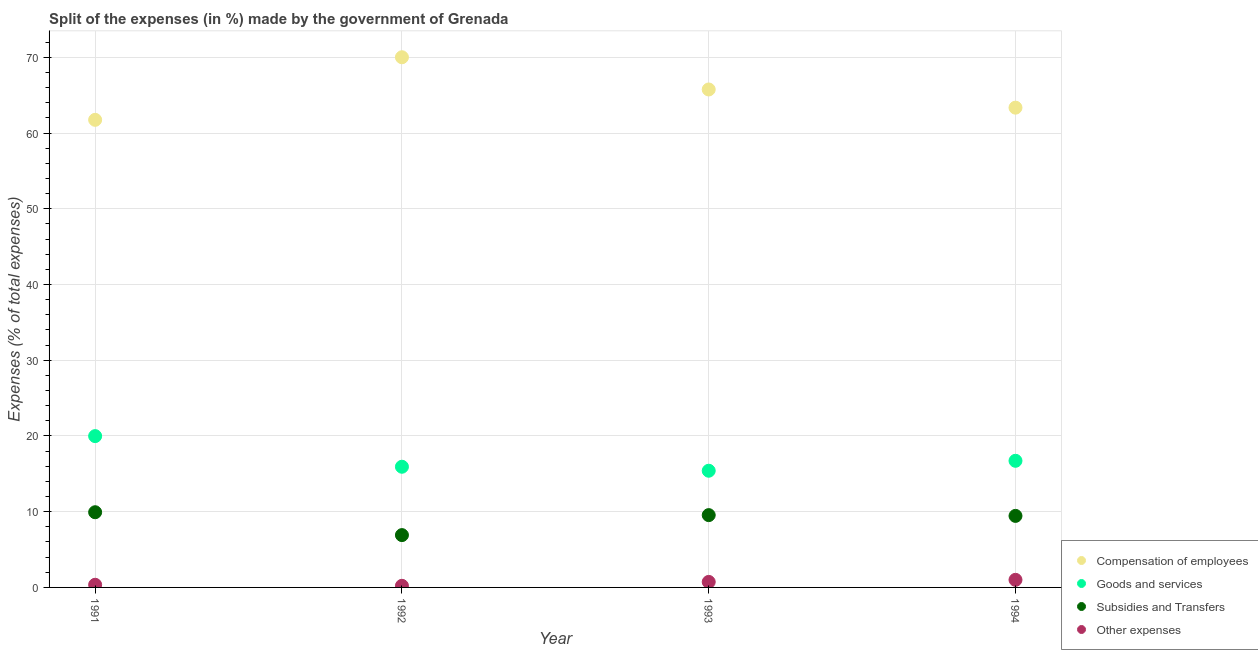Is the number of dotlines equal to the number of legend labels?
Offer a very short reply. Yes. What is the percentage of amount spent on subsidies in 1994?
Provide a short and direct response. 9.45. Across all years, what is the maximum percentage of amount spent on subsidies?
Your answer should be very brief. 9.93. Across all years, what is the minimum percentage of amount spent on subsidies?
Your answer should be very brief. 6.91. What is the total percentage of amount spent on subsidies in the graph?
Give a very brief answer. 35.84. What is the difference between the percentage of amount spent on compensation of employees in 1991 and that in 1993?
Make the answer very short. -4.01. What is the difference between the percentage of amount spent on subsidies in 1994 and the percentage of amount spent on compensation of employees in 1992?
Your answer should be compact. -60.57. What is the average percentage of amount spent on compensation of employees per year?
Ensure brevity in your answer.  65.23. In the year 1991, what is the difference between the percentage of amount spent on other expenses and percentage of amount spent on subsidies?
Your answer should be compact. -9.58. In how many years, is the percentage of amount spent on goods and services greater than 70 %?
Provide a short and direct response. 0. What is the ratio of the percentage of amount spent on goods and services in 1992 to that in 1993?
Your response must be concise. 1.03. Is the percentage of amount spent on goods and services in 1993 less than that in 1994?
Keep it short and to the point. Yes. What is the difference between the highest and the second highest percentage of amount spent on other expenses?
Ensure brevity in your answer.  0.27. What is the difference between the highest and the lowest percentage of amount spent on subsidies?
Offer a very short reply. 3.02. In how many years, is the percentage of amount spent on compensation of employees greater than the average percentage of amount spent on compensation of employees taken over all years?
Ensure brevity in your answer.  2. Is the sum of the percentage of amount spent on goods and services in 1992 and 1993 greater than the maximum percentage of amount spent on compensation of employees across all years?
Keep it short and to the point. No. Does the percentage of amount spent on subsidies monotonically increase over the years?
Provide a succinct answer. No. What is the difference between two consecutive major ticks on the Y-axis?
Offer a terse response. 10. How are the legend labels stacked?
Ensure brevity in your answer.  Vertical. What is the title of the graph?
Your answer should be very brief. Split of the expenses (in %) made by the government of Grenada. Does "Permission" appear as one of the legend labels in the graph?
Offer a very short reply. No. What is the label or title of the X-axis?
Keep it short and to the point. Year. What is the label or title of the Y-axis?
Provide a succinct answer. Expenses (% of total expenses). What is the Expenses (% of total expenses) in Compensation of employees in 1991?
Make the answer very short. 61.76. What is the Expenses (% of total expenses) of Goods and services in 1991?
Your answer should be very brief. 19.98. What is the Expenses (% of total expenses) in Subsidies and Transfers in 1991?
Make the answer very short. 9.93. What is the Expenses (% of total expenses) in Other expenses in 1991?
Your answer should be very brief. 0.35. What is the Expenses (% of total expenses) in Compensation of employees in 1992?
Provide a short and direct response. 70.02. What is the Expenses (% of total expenses) of Goods and services in 1992?
Your response must be concise. 15.94. What is the Expenses (% of total expenses) of Subsidies and Transfers in 1992?
Keep it short and to the point. 6.91. What is the Expenses (% of total expenses) of Other expenses in 1992?
Offer a terse response. 0.21. What is the Expenses (% of total expenses) of Compensation of employees in 1993?
Your response must be concise. 65.76. What is the Expenses (% of total expenses) of Goods and services in 1993?
Keep it short and to the point. 15.41. What is the Expenses (% of total expenses) in Subsidies and Transfers in 1993?
Keep it short and to the point. 9.55. What is the Expenses (% of total expenses) in Other expenses in 1993?
Provide a short and direct response. 0.73. What is the Expenses (% of total expenses) in Compensation of employees in 1994?
Give a very brief answer. 63.36. What is the Expenses (% of total expenses) in Goods and services in 1994?
Offer a terse response. 16.72. What is the Expenses (% of total expenses) in Subsidies and Transfers in 1994?
Provide a short and direct response. 9.45. What is the Expenses (% of total expenses) of Other expenses in 1994?
Ensure brevity in your answer.  1. Across all years, what is the maximum Expenses (% of total expenses) in Compensation of employees?
Your answer should be compact. 70.02. Across all years, what is the maximum Expenses (% of total expenses) in Goods and services?
Make the answer very short. 19.98. Across all years, what is the maximum Expenses (% of total expenses) of Subsidies and Transfers?
Ensure brevity in your answer.  9.93. Across all years, what is the maximum Expenses (% of total expenses) of Other expenses?
Provide a short and direct response. 1. Across all years, what is the minimum Expenses (% of total expenses) of Compensation of employees?
Provide a succinct answer. 61.76. Across all years, what is the minimum Expenses (% of total expenses) in Goods and services?
Give a very brief answer. 15.41. Across all years, what is the minimum Expenses (% of total expenses) of Subsidies and Transfers?
Offer a very short reply. 6.91. Across all years, what is the minimum Expenses (% of total expenses) of Other expenses?
Provide a short and direct response. 0.21. What is the total Expenses (% of total expenses) of Compensation of employees in the graph?
Give a very brief answer. 260.9. What is the total Expenses (% of total expenses) in Goods and services in the graph?
Provide a succinct answer. 68.06. What is the total Expenses (% of total expenses) in Subsidies and Transfers in the graph?
Your response must be concise. 35.84. What is the total Expenses (% of total expenses) of Other expenses in the graph?
Offer a terse response. 2.29. What is the difference between the Expenses (% of total expenses) in Compensation of employees in 1991 and that in 1992?
Keep it short and to the point. -8.26. What is the difference between the Expenses (% of total expenses) in Goods and services in 1991 and that in 1992?
Your answer should be very brief. 4.05. What is the difference between the Expenses (% of total expenses) in Subsidies and Transfers in 1991 and that in 1992?
Provide a succinct answer. 3.02. What is the difference between the Expenses (% of total expenses) of Other expenses in 1991 and that in 1992?
Offer a very short reply. 0.14. What is the difference between the Expenses (% of total expenses) in Compensation of employees in 1991 and that in 1993?
Make the answer very short. -4.01. What is the difference between the Expenses (% of total expenses) of Goods and services in 1991 and that in 1993?
Ensure brevity in your answer.  4.57. What is the difference between the Expenses (% of total expenses) in Subsidies and Transfers in 1991 and that in 1993?
Ensure brevity in your answer.  0.38. What is the difference between the Expenses (% of total expenses) of Other expenses in 1991 and that in 1993?
Provide a short and direct response. -0.38. What is the difference between the Expenses (% of total expenses) of Compensation of employees in 1991 and that in 1994?
Offer a terse response. -1.61. What is the difference between the Expenses (% of total expenses) in Goods and services in 1991 and that in 1994?
Your answer should be compact. 3.26. What is the difference between the Expenses (% of total expenses) of Subsidies and Transfers in 1991 and that in 1994?
Make the answer very short. 0.48. What is the difference between the Expenses (% of total expenses) of Other expenses in 1991 and that in 1994?
Give a very brief answer. -0.65. What is the difference between the Expenses (% of total expenses) in Compensation of employees in 1992 and that in 1993?
Your answer should be compact. 4.26. What is the difference between the Expenses (% of total expenses) in Goods and services in 1992 and that in 1993?
Provide a short and direct response. 0.53. What is the difference between the Expenses (% of total expenses) in Subsidies and Transfers in 1992 and that in 1993?
Offer a very short reply. -2.64. What is the difference between the Expenses (% of total expenses) of Other expenses in 1992 and that in 1993?
Offer a terse response. -0.52. What is the difference between the Expenses (% of total expenses) in Compensation of employees in 1992 and that in 1994?
Offer a terse response. 6.66. What is the difference between the Expenses (% of total expenses) of Goods and services in 1992 and that in 1994?
Your answer should be compact. -0.79. What is the difference between the Expenses (% of total expenses) in Subsidies and Transfers in 1992 and that in 1994?
Provide a succinct answer. -2.54. What is the difference between the Expenses (% of total expenses) in Other expenses in 1992 and that in 1994?
Ensure brevity in your answer.  -0.79. What is the difference between the Expenses (% of total expenses) of Compensation of employees in 1993 and that in 1994?
Provide a short and direct response. 2.4. What is the difference between the Expenses (% of total expenses) of Goods and services in 1993 and that in 1994?
Your answer should be compact. -1.31. What is the difference between the Expenses (% of total expenses) in Subsidies and Transfers in 1993 and that in 1994?
Keep it short and to the point. 0.1. What is the difference between the Expenses (% of total expenses) of Other expenses in 1993 and that in 1994?
Provide a succinct answer. -0.27. What is the difference between the Expenses (% of total expenses) of Compensation of employees in 1991 and the Expenses (% of total expenses) of Goods and services in 1992?
Give a very brief answer. 45.82. What is the difference between the Expenses (% of total expenses) in Compensation of employees in 1991 and the Expenses (% of total expenses) in Subsidies and Transfers in 1992?
Keep it short and to the point. 54.84. What is the difference between the Expenses (% of total expenses) of Compensation of employees in 1991 and the Expenses (% of total expenses) of Other expenses in 1992?
Provide a short and direct response. 61.54. What is the difference between the Expenses (% of total expenses) of Goods and services in 1991 and the Expenses (% of total expenses) of Subsidies and Transfers in 1992?
Your answer should be compact. 13.07. What is the difference between the Expenses (% of total expenses) in Goods and services in 1991 and the Expenses (% of total expenses) in Other expenses in 1992?
Offer a terse response. 19.77. What is the difference between the Expenses (% of total expenses) of Subsidies and Transfers in 1991 and the Expenses (% of total expenses) of Other expenses in 1992?
Offer a terse response. 9.72. What is the difference between the Expenses (% of total expenses) in Compensation of employees in 1991 and the Expenses (% of total expenses) in Goods and services in 1993?
Offer a very short reply. 46.34. What is the difference between the Expenses (% of total expenses) in Compensation of employees in 1991 and the Expenses (% of total expenses) in Subsidies and Transfers in 1993?
Offer a terse response. 52.21. What is the difference between the Expenses (% of total expenses) of Compensation of employees in 1991 and the Expenses (% of total expenses) of Other expenses in 1993?
Ensure brevity in your answer.  61.03. What is the difference between the Expenses (% of total expenses) in Goods and services in 1991 and the Expenses (% of total expenses) in Subsidies and Transfers in 1993?
Provide a short and direct response. 10.43. What is the difference between the Expenses (% of total expenses) in Goods and services in 1991 and the Expenses (% of total expenses) in Other expenses in 1993?
Provide a short and direct response. 19.26. What is the difference between the Expenses (% of total expenses) in Subsidies and Transfers in 1991 and the Expenses (% of total expenses) in Other expenses in 1993?
Offer a terse response. 9.2. What is the difference between the Expenses (% of total expenses) of Compensation of employees in 1991 and the Expenses (% of total expenses) of Goods and services in 1994?
Your answer should be compact. 45.03. What is the difference between the Expenses (% of total expenses) in Compensation of employees in 1991 and the Expenses (% of total expenses) in Subsidies and Transfers in 1994?
Ensure brevity in your answer.  52.31. What is the difference between the Expenses (% of total expenses) in Compensation of employees in 1991 and the Expenses (% of total expenses) in Other expenses in 1994?
Your answer should be very brief. 60.75. What is the difference between the Expenses (% of total expenses) of Goods and services in 1991 and the Expenses (% of total expenses) of Subsidies and Transfers in 1994?
Offer a terse response. 10.54. What is the difference between the Expenses (% of total expenses) of Goods and services in 1991 and the Expenses (% of total expenses) of Other expenses in 1994?
Provide a succinct answer. 18.98. What is the difference between the Expenses (% of total expenses) of Subsidies and Transfers in 1991 and the Expenses (% of total expenses) of Other expenses in 1994?
Your answer should be very brief. 8.93. What is the difference between the Expenses (% of total expenses) of Compensation of employees in 1992 and the Expenses (% of total expenses) of Goods and services in 1993?
Your answer should be very brief. 54.61. What is the difference between the Expenses (% of total expenses) of Compensation of employees in 1992 and the Expenses (% of total expenses) of Subsidies and Transfers in 1993?
Provide a short and direct response. 60.47. What is the difference between the Expenses (% of total expenses) in Compensation of employees in 1992 and the Expenses (% of total expenses) in Other expenses in 1993?
Keep it short and to the point. 69.29. What is the difference between the Expenses (% of total expenses) of Goods and services in 1992 and the Expenses (% of total expenses) of Subsidies and Transfers in 1993?
Your answer should be very brief. 6.39. What is the difference between the Expenses (% of total expenses) in Goods and services in 1992 and the Expenses (% of total expenses) in Other expenses in 1993?
Offer a very short reply. 15.21. What is the difference between the Expenses (% of total expenses) in Subsidies and Transfers in 1992 and the Expenses (% of total expenses) in Other expenses in 1993?
Offer a very short reply. 6.18. What is the difference between the Expenses (% of total expenses) in Compensation of employees in 1992 and the Expenses (% of total expenses) in Goods and services in 1994?
Provide a succinct answer. 53.3. What is the difference between the Expenses (% of total expenses) in Compensation of employees in 1992 and the Expenses (% of total expenses) in Subsidies and Transfers in 1994?
Offer a terse response. 60.57. What is the difference between the Expenses (% of total expenses) in Compensation of employees in 1992 and the Expenses (% of total expenses) in Other expenses in 1994?
Keep it short and to the point. 69.02. What is the difference between the Expenses (% of total expenses) in Goods and services in 1992 and the Expenses (% of total expenses) in Subsidies and Transfers in 1994?
Provide a short and direct response. 6.49. What is the difference between the Expenses (% of total expenses) of Goods and services in 1992 and the Expenses (% of total expenses) of Other expenses in 1994?
Keep it short and to the point. 14.94. What is the difference between the Expenses (% of total expenses) in Subsidies and Transfers in 1992 and the Expenses (% of total expenses) in Other expenses in 1994?
Provide a succinct answer. 5.91. What is the difference between the Expenses (% of total expenses) of Compensation of employees in 1993 and the Expenses (% of total expenses) of Goods and services in 1994?
Ensure brevity in your answer.  49.04. What is the difference between the Expenses (% of total expenses) of Compensation of employees in 1993 and the Expenses (% of total expenses) of Subsidies and Transfers in 1994?
Offer a terse response. 56.32. What is the difference between the Expenses (% of total expenses) of Compensation of employees in 1993 and the Expenses (% of total expenses) of Other expenses in 1994?
Your response must be concise. 64.76. What is the difference between the Expenses (% of total expenses) of Goods and services in 1993 and the Expenses (% of total expenses) of Subsidies and Transfers in 1994?
Your answer should be compact. 5.96. What is the difference between the Expenses (% of total expenses) of Goods and services in 1993 and the Expenses (% of total expenses) of Other expenses in 1994?
Provide a short and direct response. 14.41. What is the difference between the Expenses (% of total expenses) of Subsidies and Transfers in 1993 and the Expenses (% of total expenses) of Other expenses in 1994?
Offer a terse response. 8.55. What is the average Expenses (% of total expenses) in Compensation of employees per year?
Make the answer very short. 65.23. What is the average Expenses (% of total expenses) in Goods and services per year?
Your answer should be very brief. 17.01. What is the average Expenses (% of total expenses) in Subsidies and Transfers per year?
Provide a short and direct response. 8.96. What is the average Expenses (% of total expenses) of Other expenses per year?
Ensure brevity in your answer.  0.57. In the year 1991, what is the difference between the Expenses (% of total expenses) in Compensation of employees and Expenses (% of total expenses) in Goods and services?
Make the answer very short. 41.77. In the year 1991, what is the difference between the Expenses (% of total expenses) of Compensation of employees and Expenses (% of total expenses) of Subsidies and Transfers?
Your answer should be very brief. 51.82. In the year 1991, what is the difference between the Expenses (% of total expenses) of Compensation of employees and Expenses (% of total expenses) of Other expenses?
Provide a short and direct response. 61.4. In the year 1991, what is the difference between the Expenses (% of total expenses) in Goods and services and Expenses (% of total expenses) in Subsidies and Transfers?
Ensure brevity in your answer.  10.05. In the year 1991, what is the difference between the Expenses (% of total expenses) of Goods and services and Expenses (% of total expenses) of Other expenses?
Provide a succinct answer. 19.63. In the year 1991, what is the difference between the Expenses (% of total expenses) in Subsidies and Transfers and Expenses (% of total expenses) in Other expenses?
Your answer should be very brief. 9.58. In the year 1992, what is the difference between the Expenses (% of total expenses) of Compensation of employees and Expenses (% of total expenses) of Goods and services?
Offer a terse response. 54.08. In the year 1992, what is the difference between the Expenses (% of total expenses) in Compensation of employees and Expenses (% of total expenses) in Subsidies and Transfers?
Make the answer very short. 63.11. In the year 1992, what is the difference between the Expenses (% of total expenses) of Compensation of employees and Expenses (% of total expenses) of Other expenses?
Provide a succinct answer. 69.81. In the year 1992, what is the difference between the Expenses (% of total expenses) of Goods and services and Expenses (% of total expenses) of Subsidies and Transfers?
Provide a short and direct response. 9.03. In the year 1992, what is the difference between the Expenses (% of total expenses) of Goods and services and Expenses (% of total expenses) of Other expenses?
Your answer should be compact. 15.73. In the year 1992, what is the difference between the Expenses (% of total expenses) of Subsidies and Transfers and Expenses (% of total expenses) of Other expenses?
Offer a terse response. 6.7. In the year 1993, what is the difference between the Expenses (% of total expenses) of Compensation of employees and Expenses (% of total expenses) of Goods and services?
Make the answer very short. 50.35. In the year 1993, what is the difference between the Expenses (% of total expenses) of Compensation of employees and Expenses (% of total expenses) of Subsidies and Transfers?
Your answer should be compact. 56.21. In the year 1993, what is the difference between the Expenses (% of total expenses) in Compensation of employees and Expenses (% of total expenses) in Other expenses?
Give a very brief answer. 65.04. In the year 1993, what is the difference between the Expenses (% of total expenses) of Goods and services and Expenses (% of total expenses) of Subsidies and Transfers?
Keep it short and to the point. 5.86. In the year 1993, what is the difference between the Expenses (% of total expenses) of Goods and services and Expenses (% of total expenses) of Other expenses?
Offer a terse response. 14.68. In the year 1993, what is the difference between the Expenses (% of total expenses) in Subsidies and Transfers and Expenses (% of total expenses) in Other expenses?
Offer a terse response. 8.82. In the year 1994, what is the difference between the Expenses (% of total expenses) in Compensation of employees and Expenses (% of total expenses) in Goods and services?
Offer a very short reply. 46.64. In the year 1994, what is the difference between the Expenses (% of total expenses) in Compensation of employees and Expenses (% of total expenses) in Subsidies and Transfers?
Your response must be concise. 53.91. In the year 1994, what is the difference between the Expenses (% of total expenses) of Compensation of employees and Expenses (% of total expenses) of Other expenses?
Give a very brief answer. 62.36. In the year 1994, what is the difference between the Expenses (% of total expenses) of Goods and services and Expenses (% of total expenses) of Subsidies and Transfers?
Your answer should be very brief. 7.28. In the year 1994, what is the difference between the Expenses (% of total expenses) in Goods and services and Expenses (% of total expenses) in Other expenses?
Provide a short and direct response. 15.72. In the year 1994, what is the difference between the Expenses (% of total expenses) of Subsidies and Transfers and Expenses (% of total expenses) of Other expenses?
Make the answer very short. 8.45. What is the ratio of the Expenses (% of total expenses) in Compensation of employees in 1991 to that in 1992?
Give a very brief answer. 0.88. What is the ratio of the Expenses (% of total expenses) of Goods and services in 1991 to that in 1992?
Give a very brief answer. 1.25. What is the ratio of the Expenses (% of total expenses) in Subsidies and Transfers in 1991 to that in 1992?
Offer a terse response. 1.44. What is the ratio of the Expenses (% of total expenses) of Other expenses in 1991 to that in 1992?
Provide a short and direct response. 1.65. What is the ratio of the Expenses (% of total expenses) of Compensation of employees in 1991 to that in 1993?
Offer a terse response. 0.94. What is the ratio of the Expenses (% of total expenses) in Goods and services in 1991 to that in 1993?
Ensure brevity in your answer.  1.3. What is the ratio of the Expenses (% of total expenses) of Subsidies and Transfers in 1991 to that in 1993?
Make the answer very short. 1.04. What is the ratio of the Expenses (% of total expenses) in Other expenses in 1991 to that in 1993?
Ensure brevity in your answer.  0.48. What is the ratio of the Expenses (% of total expenses) of Compensation of employees in 1991 to that in 1994?
Your response must be concise. 0.97. What is the ratio of the Expenses (% of total expenses) in Goods and services in 1991 to that in 1994?
Provide a succinct answer. 1.2. What is the ratio of the Expenses (% of total expenses) in Subsidies and Transfers in 1991 to that in 1994?
Ensure brevity in your answer.  1.05. What is the ratio of the Expenses (% of total expenses) of Other expenses in 1991 to that in 1994?
Keep it short and to the point. 0.35. What is the ratio of the Expenses (% of total expenses) in Compensation of employees in 1992 to that in 1993?
Your answer should be compact. 1.06. What is the ratio of the Expenses (% of total expenses) in Goods and services in 1992 to that in 1993?
Make the answer very short. 1.03. What is the ratio of the Expenses (% of total expenses) in Subsidies and Transfers in 1992 to that in 1993?
Ensure brevity in your answer.  0.72. What is the ratio of the Expenses (% of total expenses) of Other expenses in 1992 to that in 1993?
Your answer should be very brief. 0.29. What is the ratio of the Expenses (% of total expenses) of Compensation of employees in 1992 to that in 1994?
Offer a terse response. 1.11. What is the ratio of the Expenses (% of total expenses) in Goods and services in 1992 to that in 1994?
Provide a succinct answer. 0.95. What is the ratio of the Expenses (% of total expenses) in Subsidies and Transfers in 1992 to that in 1994?
Your answer should be compact. 0.73. What is the ratio of the Expenses (% of total expenses) of Other expenses in 1992 to that in 1994?
Make the answer very short. 0.21. What is the ratio of the Expenses (% of total expenses) in Compensation of employees in 1993 to that in 1994?
Provide a short and direct response. 1.04. What is the ratio of the Expenses (% of total expenses) of Goods and services in 1993 to that in 1994?
Your response must be concise. 0.92. What is the ratio of the Expenses (% of total expenses) in Subsidies and Transfers in 1993 to that in 1994?
Offer a very short reply. 1.01. What is the ratio of the Expenses (% of total expenses) of Other expenses in 1993 to that in 1994?
Offer a very short reply. 0.73. What is the difference between the highest and the second highest Expenses (% of total expenses) of Compensation of employees?
Keep it short and to the point. 4.26. What is the difference between the highest and the second highest Expenses (% of total expenses) in Goods and services?
Ensure brevity in your answer.  3.26. What is the difference between the highest and the second highest Expenses (% of total expenses) in Subsidies and Transfers?
Provide a short and direct response. 0.38. What is the difference between the highest and the second highest Expenses (% of total expenses) of Other expenses?
Provide a succinct answer. 0.27. What is the difference between the highest and the lowest Expenses (% of total expenses) in Compensation of employees?
Provide a succinct answer. 8.26. What is the difference between the highest and the lowest Expenses (% of total expenses) in Goods and services?
Give a very brief answer. 4.57. What is the difference between the highest and the lowest Expenses (% of total expenses) in Subsidies and Transfers?
Provide a short and direct response. 3.02. What is the difference between the highest and the lowest Expenses (% of total expenses) of Other expenses?
Give a very brief answer. 0.79. 